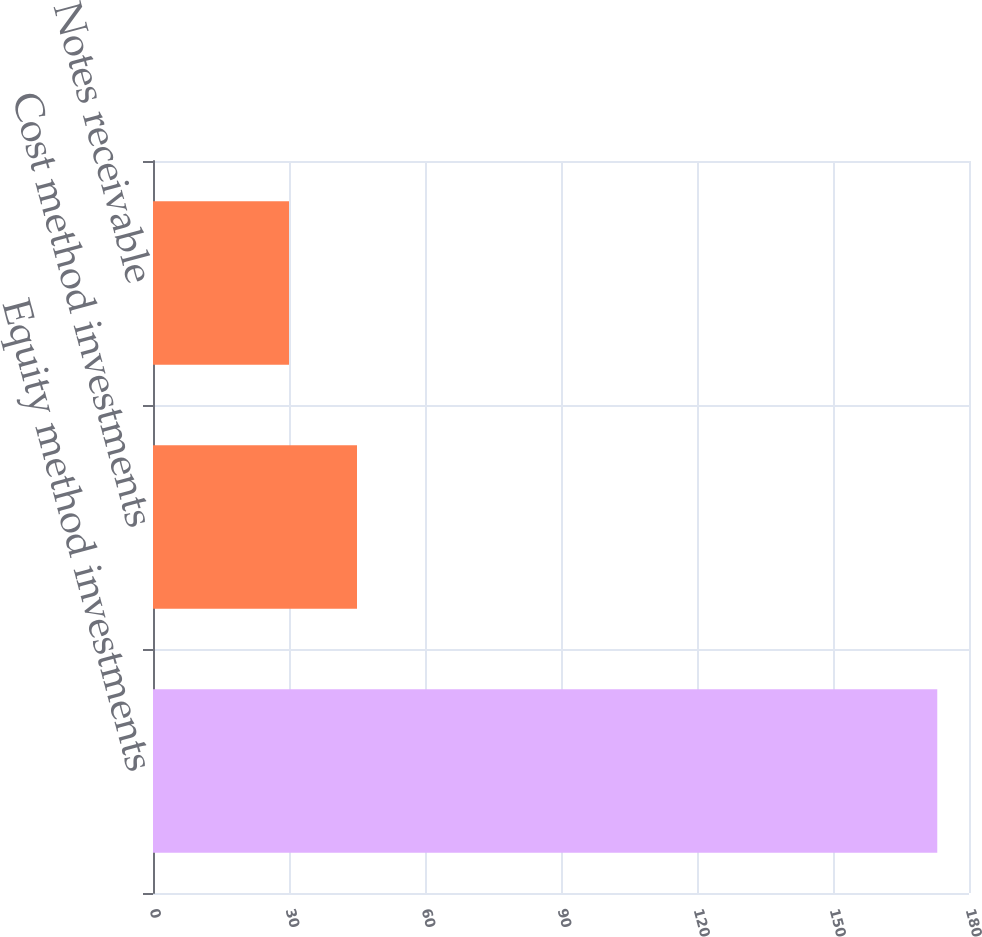<chart> <loc_0><loc_0><loc_500><loc_500><bar_chart><fcel>Equity method investments<fcel>Cost method investments<fcel>Notes receivable<nl><fcel>173<fcel>45<fcel>30<nl></chart> 